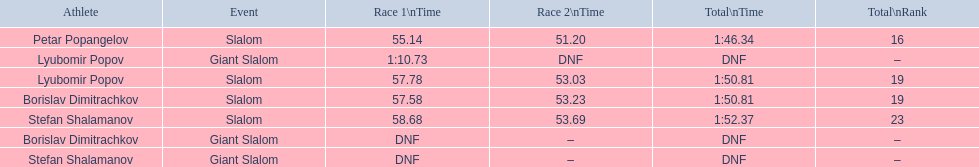What are all the competitions lyubomir popov competed in? Lyubomir Popov, Lyubomir Popov. Of those, which were giant slalom races? Giant Slalom. What was his time in race 1? 1:10.73. 